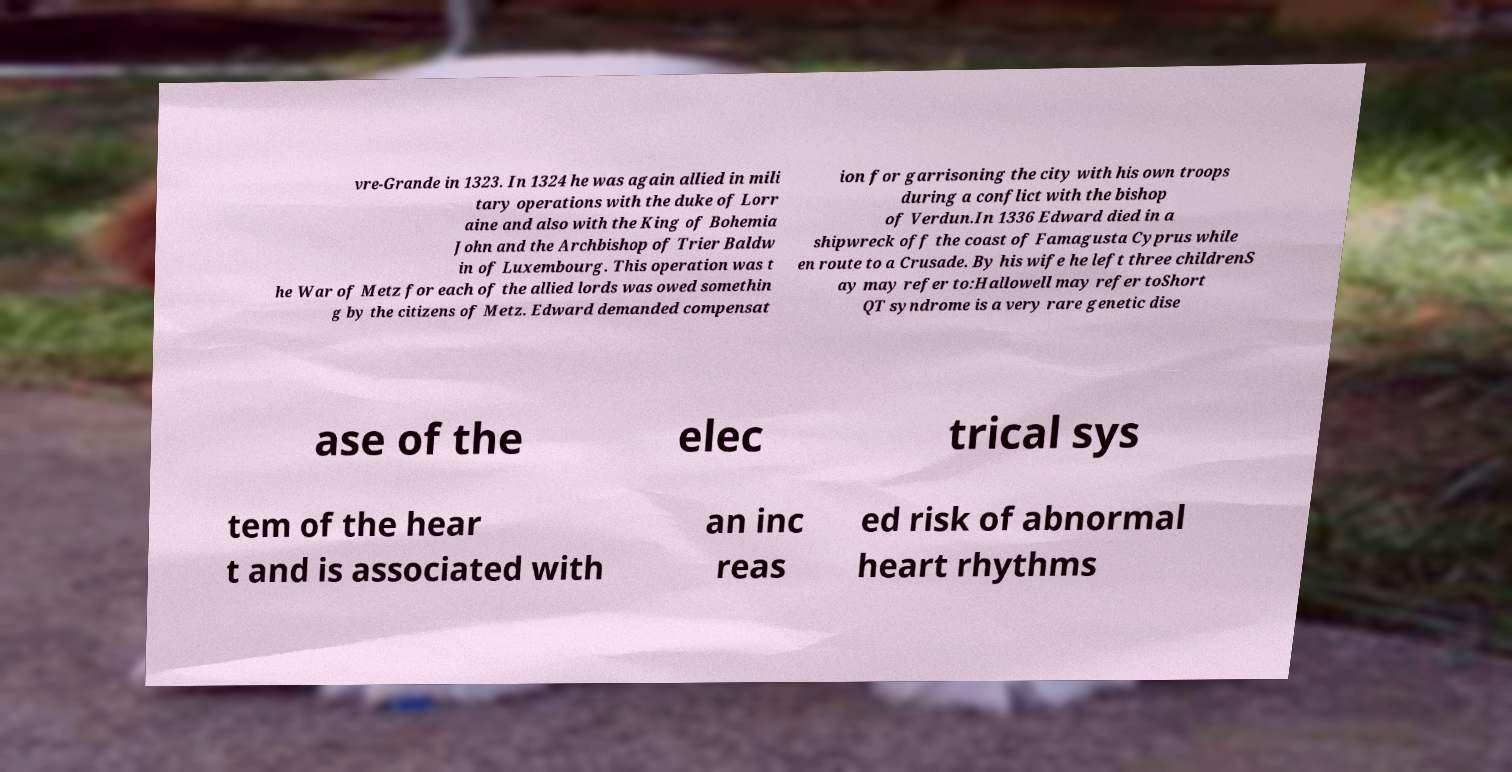What messages or text are displayed in this image? I need them in a readable, typed format. vre-Grande in 1323. In 1324 he was again allied in mili tary operations with the duke of Lorr aine and also with the King of Bohemia John and the Archbishop of Trier Baldw in of Luxembourg. This operation was t he War of Metz for each of the allied lords was owed somethin g by the citizens of Metz. Edward demanded compensat ion for garrisoning the city with his own troops during a conflict with the bishop of Verdun.In 1336 Edward died in a shipwreck off the coast of Famagusta Cyprus while en route to a Crusade. By his wife he left three childrenS ay may refer to:Hallowell may refer toShort QT syndrome is a very rare genetic dise ase of the elec trical sys tem of the hear t and is associated with an inc reas ed risk of abnormal heart rhythms 